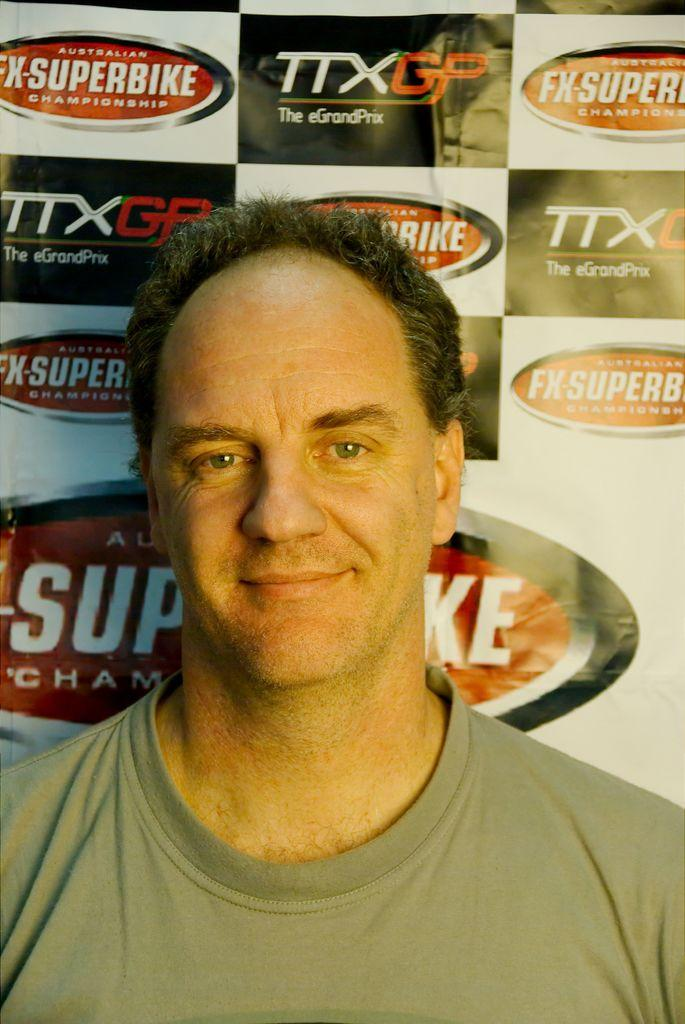What is present in the image? There is a person in the image. How does the person appear in the image? The person has a smiling face. What can be seen in the background of the image? There is a banner with text in the background of the image. What type of rice is being cooked in the image? There is no rice or cooking activity present in the image. How much shade is provided by the person in the image? The person in the image is not providing any shade, as they are not an object that can cast a shadow. 